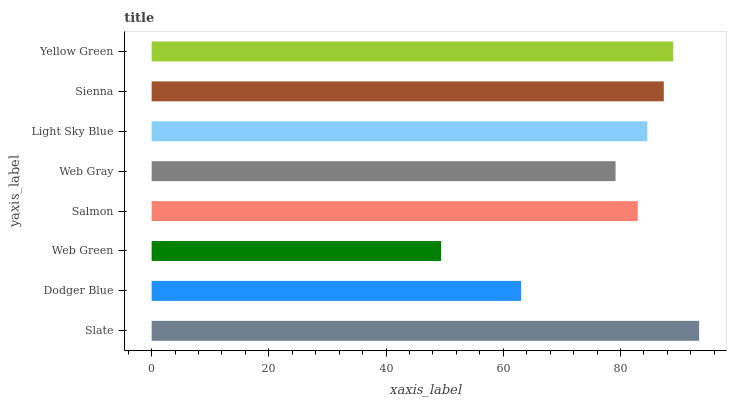Is Web Green the minimum?
Answer yes or no. Yes. Is Slate the maximum?
Answer yes or no. Yes. Is Dodger Blue the minimum?
Answer yes or no. No. Is Dodger Blue the maximum?
Answer yes or no. No. Is Slate greater than Dodger Blue?
Answer yes or no. Yes. Is Dodger Blue less than Slate?
Answer yes or no. Yes. Is Dodger Blue greater than Slate?
Answer yes or no. No. Is Slate less than Dodger Blue?
Answer yes or no. No. Is Light Sky Blue the high median?
Answer yes or no. Yes. Is Salmon the low median?
Answer yes or no. Yes. Is Salmon the high median?
Answer yes or no. No. Is Slate the low median?
Answer yes or no. No. 